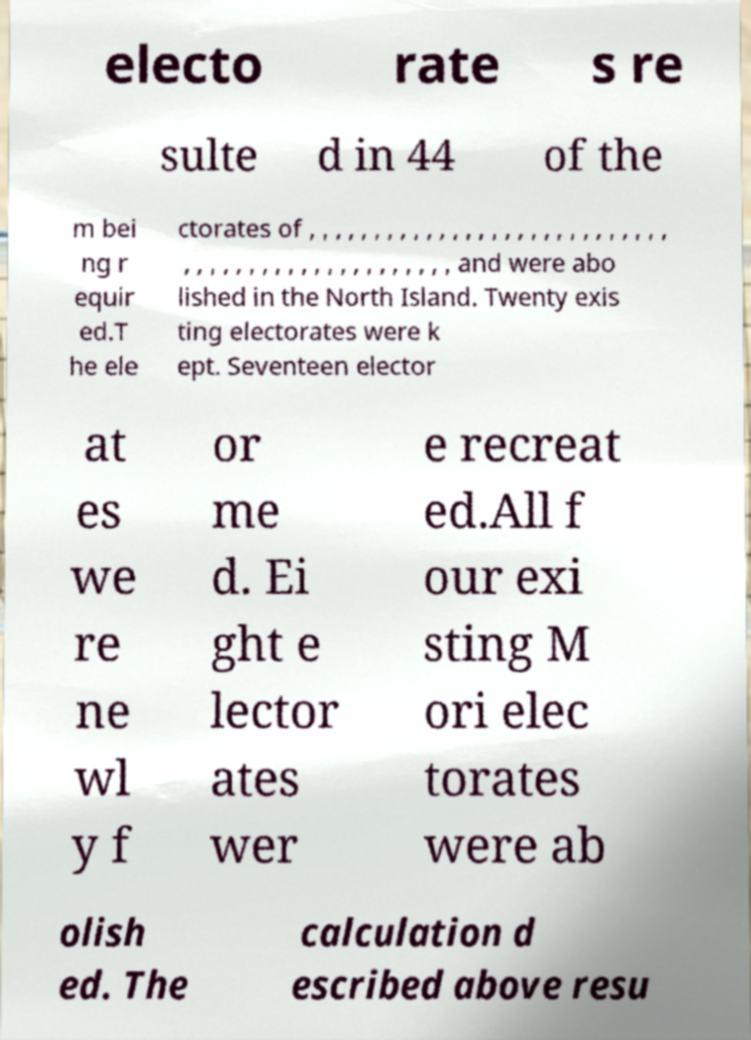Can you accurately transcribe the text from the provided image for me? electo rate s re sulte d in 44 of the m bei ng r equir ed.T he ele ctorates of , , , , , , , , , , , , , , , , , , , , , , , , , , , , , , , , , , , , , , , , , , , , , , , , , and were abo lished in the North Island. Twenty exis ting electorates were k ept. Seventeen elector at es we re ne wl y f or me d. Ei ght e lector ates wer e recreat ed.All f our exi sting M ori elec torates were ab olish ed. The calculation d escribed above resu 